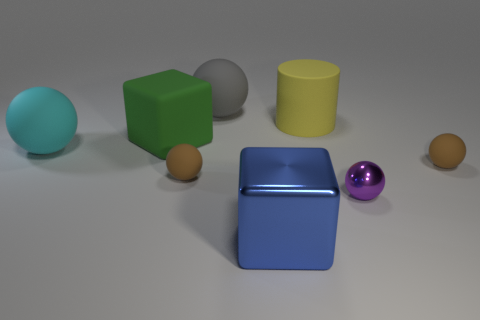There is a brown matte thing that is to the left of the yellow matte object; is its shape the same as the tiny purple metal thing?
Offer a very short reply. Yes. Is the number of big yellow matte things that are to the right of the yellow matte cylinder less than the number of purple spheres left of the big cyan thing?
Your response must be concise. No. There is a brown sphere left of the large cylinder; what material is it?
Offer a very short reply. Rubber. Is there a cylinder of the same size as the cyan rubber ball?
Provide a short and direct response. Yes. Do the large cyan object and the big gray object behind the green block have the same shape?
Provide a short and direct response. Yes. Do the ball behind the cyan rubber thing and the metal object on the right side of the metallic block have the same size?
Provide a short and direct response. No. What number of other objects are the same shape as the small metal thing?
Your answer should be very brief. 4. What is the brown sphere that is to the right of the large object in front of the tiny metal sphere made of?
Provide a short and direct response. Rubber. How many shiny objects are either green cubes or cyan spheres?
Give a very brief answer. 0. Is there any other thing that is the same material as the cyan sphere?
Your answer should be very brief. Yes. 